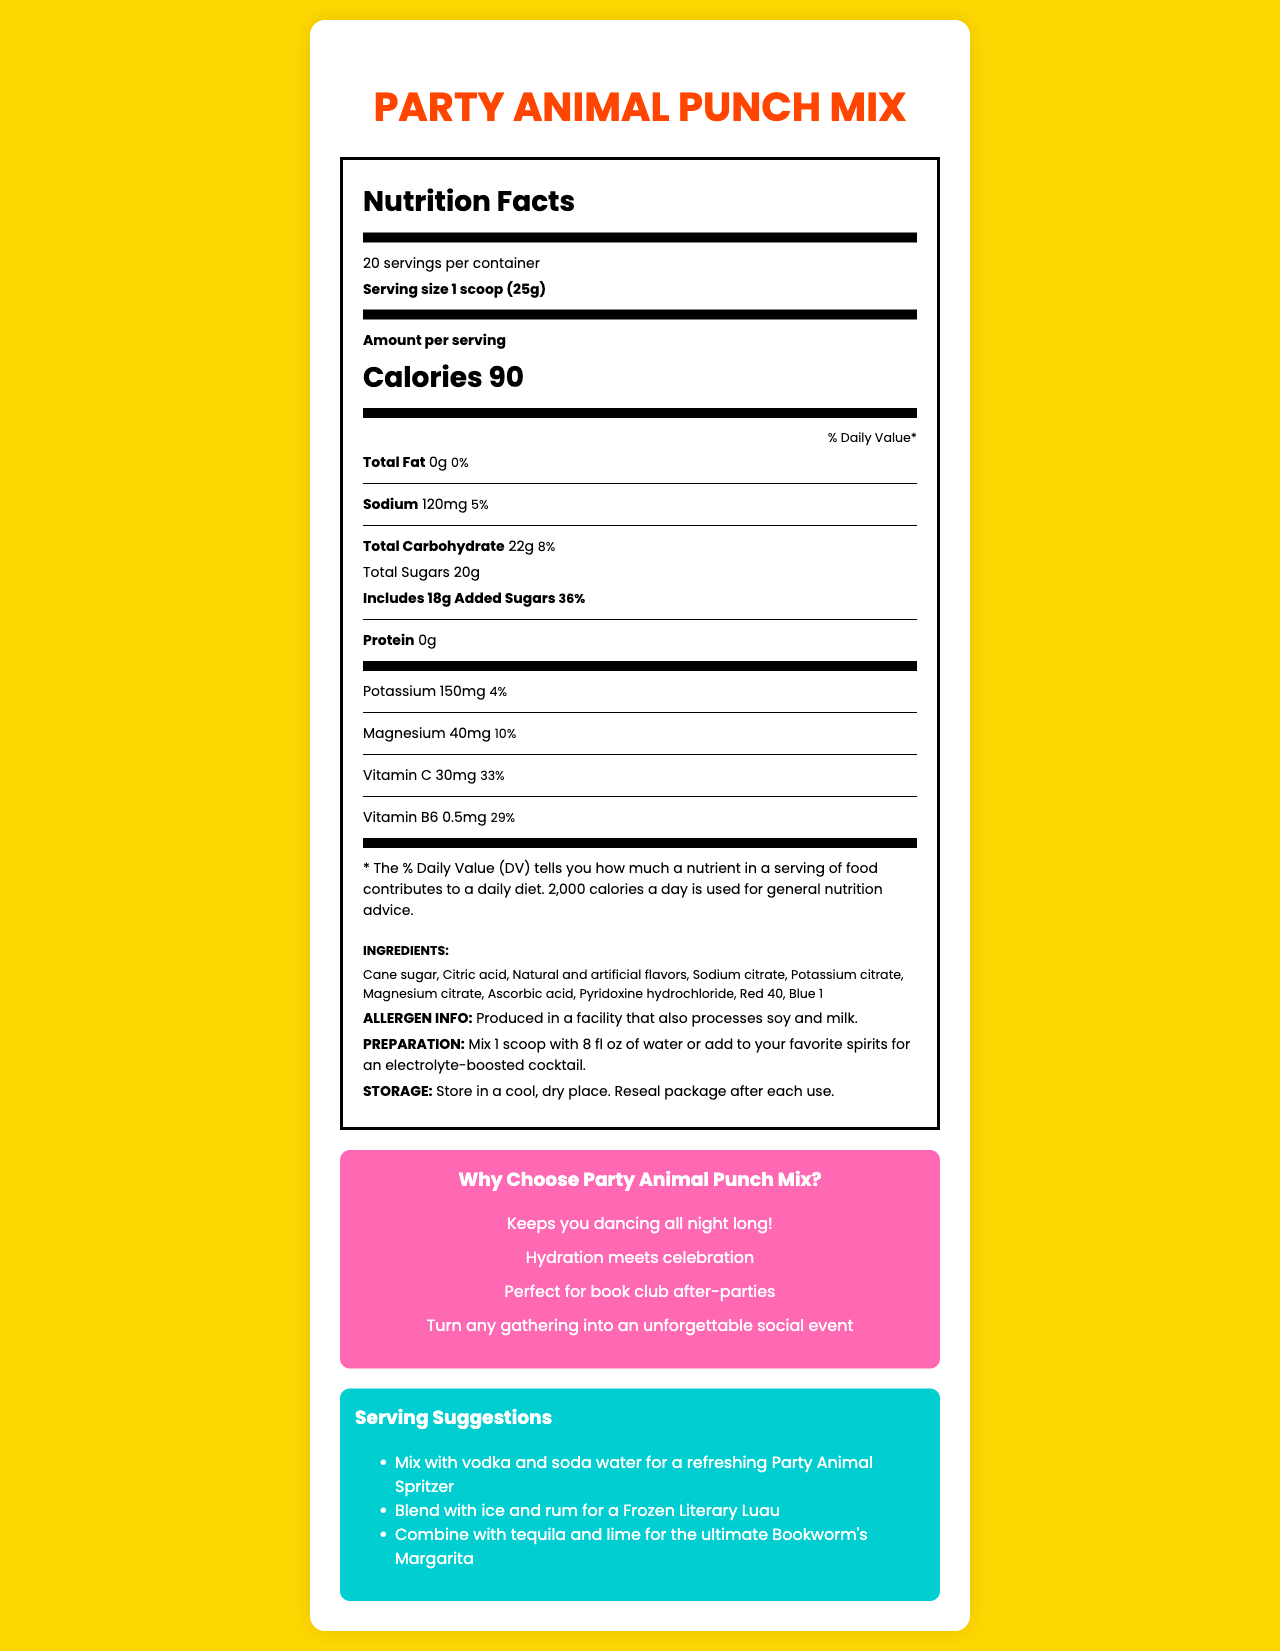how many servings are in the Party Animal Punch Mix container? The document states that there are 20 servings per container.
Answer: 20 what is the serving size for the Party Animal Punch Mix? The document specifies the serving size as 1 scoop (25g).
Answer: 1 scoop (25g) how many calories are there per serving? The document indicates that there are 90 calories per serving of the punch mix.
Answer: 90 how much total fat is in one serving? The nutrition facts label shows that there is 0g of total fat, which is 0% of the daily value.
Answer: 0g, 0% list some of the electrolytes included in this punch mix. The nutrition facts label lists Sodium (120mg), Potassium (150mg), and Magnesium (40mg) as included electrolytes.
Answer: Sodium, Potassium, Magnesium what is the percentage of daily value for added sugars? The document states that the added sugars amount to 18g, which is 36% of the daily value.
Answer: 36% is the punch mix suitable for someone with a milk allergy? The document mentions that the product is produced in a facility that processes milk, which may not be safe for someone with a milk allergy.
Answer: No which vitamin has the highest daily value percentage in this product? A. Vitamin C B. Vitamin B6 C. Magnesium Vitamin C has a daily value of 33%, Vitamin B6 has 29%, and Magnesium has 10%. Therefore, Vitamin C has the highest percentage.
Answer: A what are some of the suggested ways to serve Party Animal Punch Mix? The document provides serving suggestions including mixing with vodka and soda water, blending with ice and rum, and combining with tequila and lime.
Answer: Mix with vodka and soda water, Blend with ice and rum, Combine with tequila and lime which ingredient gives the punch mix its color? A. Cane sugar B. Red 40 C. Ascorbic acid D. Citric acid Red 40 is one of the coloring agents listed in the ingredients.
Answer: B is there any protein in each serving of the punch mix? The document shows that there is 0g of protein per serving.
Answer: No describe the main idea of the document. The document acts as an informative guide about the Party Animal Punch Mix, detailing its nutritional facts, ingredients, preparation methods, marketing claims, and serving suggestions to give the user a complete understanding of the product.
Answer: The main idea of the document is to provide detailed nutrition facts, ingredients, and other information about the Party Animal Punch Mix, a festive punch with added electrolytes. It highlights its nutritional content, serving suggestions, preparation instructions, and marketing claims. what is the recommended storage condition for the Party Animal Punch Mix? The document states to store the punch mix in a cool, dry place and reseal the package after each use.
Answer: Store in a cool, dry place. Reseal package after each use. how much vitamin C is in one serving, and what is its daily value percentage? The document lists that one serving contains 30mg of vitamin C, which is 33% of the daily value.
Answer: 30mg, 33% what are the potential allergens in the punch mix? The document notes that the product is produced in a facility that processes soy and milk, indicating potential allergen contamination.
Answer: Soy and milk which marketing claim suggests that the punch mix is suitable for intellectual gatherings? The marketing claim states "Perfect for book club after-parties" indicating its suitability for intellectual or literary gatherings.
Answer: Perfect for book club after-parties does the punch mix contain any fiber? The document does not provide any information on the dietary fiber content of the punch mix.
Answer: Cannot be determined 